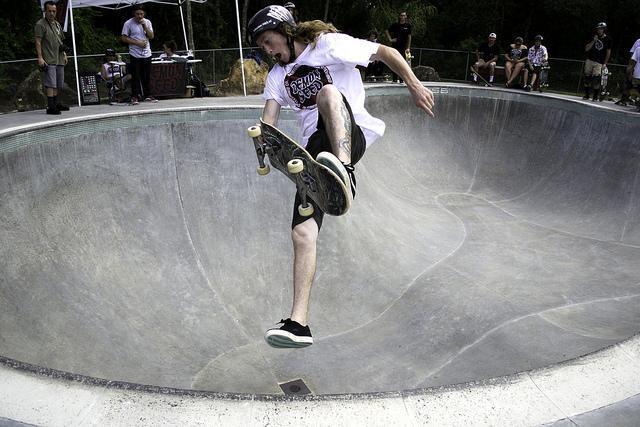How many people are skating?
Give a very brief answer. 1. How many people are in the picture?
Give a very brief answer. 3. 